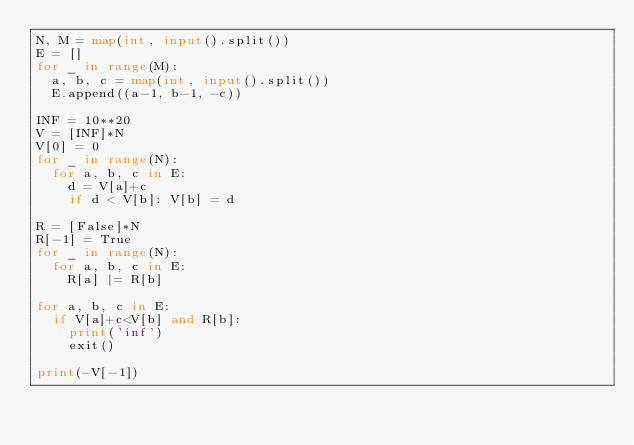<code> <loc_0><loc_0><loc_500><loc_500><_Python_>N, M = map(int, input().split())
E = []
for _ in range(M):
  a, b, c = map(int, input().split())
  E.append((a-1, b-1, -c))

INF = 10**20
V = [INF]*N
V[0] = 0
for _ in range(N):
  for a, b, c in E:
    d = V[a]+c
    if d < V[b]: V[b] = d

R = [False]*N
R[-1] = True
for _ in range(N):
  for a, b, c in E:
    R[a] |= R[b]

for a, b, c in E:
  if V[a]+c<V[b] and R[b]:
    print('inf')
    exit()
    
print(-V[-1])</code> 